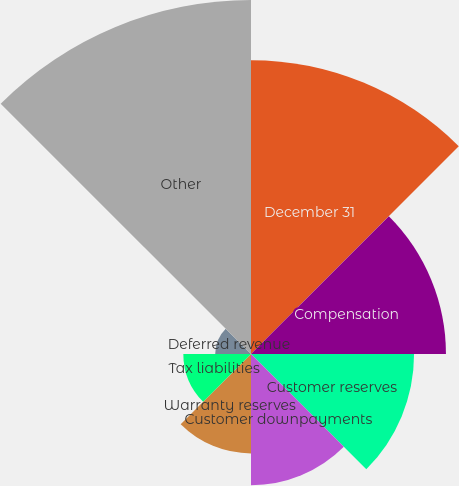Convert chart. <chart><loc_0><loc_0><loc_500><loc_500><pie_chart><fcel>December 31<fcel>Compensation<fcel>Customer reserves<fcel>Customer downpayments<fcel>Warranty reserves<fcel>Tax liabilities<fcel>Deferred revenue<fcel>Other<nl><fcel>21.93%<fcel>14.55%<fcel>12.17%<fcel>9.8%<fcel>7.42%<fcel>5.05%<fcel>2.67%<fcel>26.42%<nl></chart> 